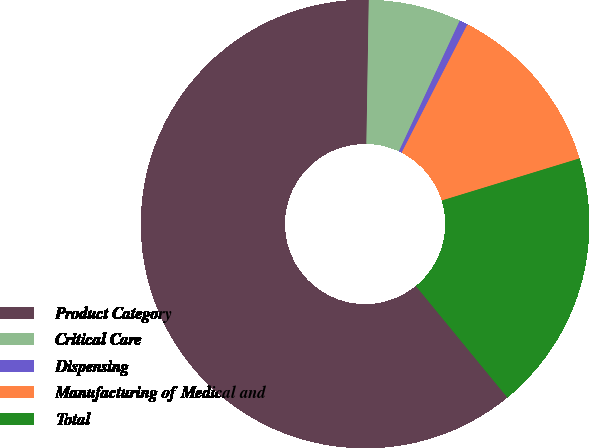<chart> <loc_0><loc_0><loc_500><loc_500><pie_chart><fcel>Product Category<fcel>Critical Care<fcel>Dispensing<fcel>Manufacturing of Medical and<fcel>Total<nl><fcel>61.2%<fcel>6.67%<fcel>0.61%<fcel>12.73%<fcel>18.79%<nl></chart> 